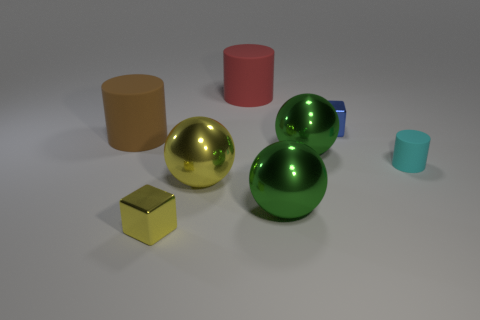Subtract all big red rubber cylinders. How many cylinders are left? 2 Subtract all blue blocks. How many green balls are left? 2 Add 2 shiny balls. How many objects exist? 10 Subtract 1 blocks. How many blocks are left? 1 Subtract all cylinders. How many objects are left? 5 Subtract all yellow cylinders. Subtract all purple cubes. How many cylinders are left? 3 Add 2 tiny cyan matte things. How many tiny cyan matte things are left? 3 Add 1 gray rubber cylinders. How many gray rubber cylinders exist? 1 Subtract 0 purple spheres. How many objects are left? 8 Subtract all big yellow matte blocks. Subtract all red cylinders. How many objects are left? 7 